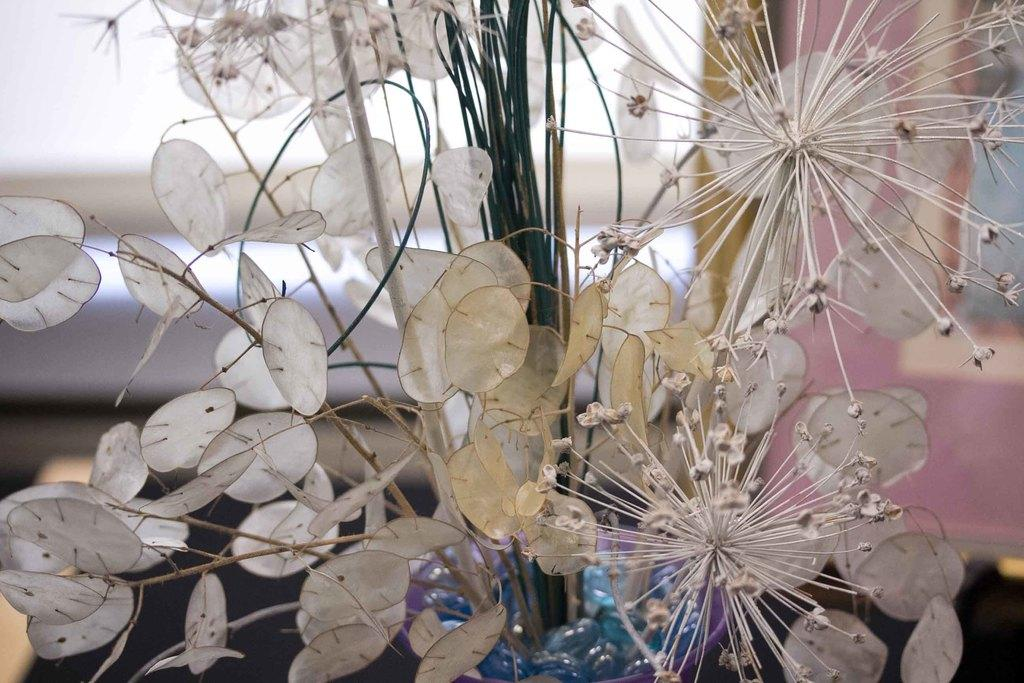What is the main subject of the picture? The main subject of the picture is a plant. What is unique about the plant's appearance? The plant has white leaves. Can you describe any other objects or elements in the background of the image? There are other objects in the background of the image, but their specific details are not mentioned in the provided facts. Can you tell me how many kittens are playing with the grandfather in the image? There are no kittens or grandfathers present in the image; it features a plant with white leaves. How many lizards are climbing on the plant in the image? There are no lizards visible in the image; it only shows a plant with white leaves. 